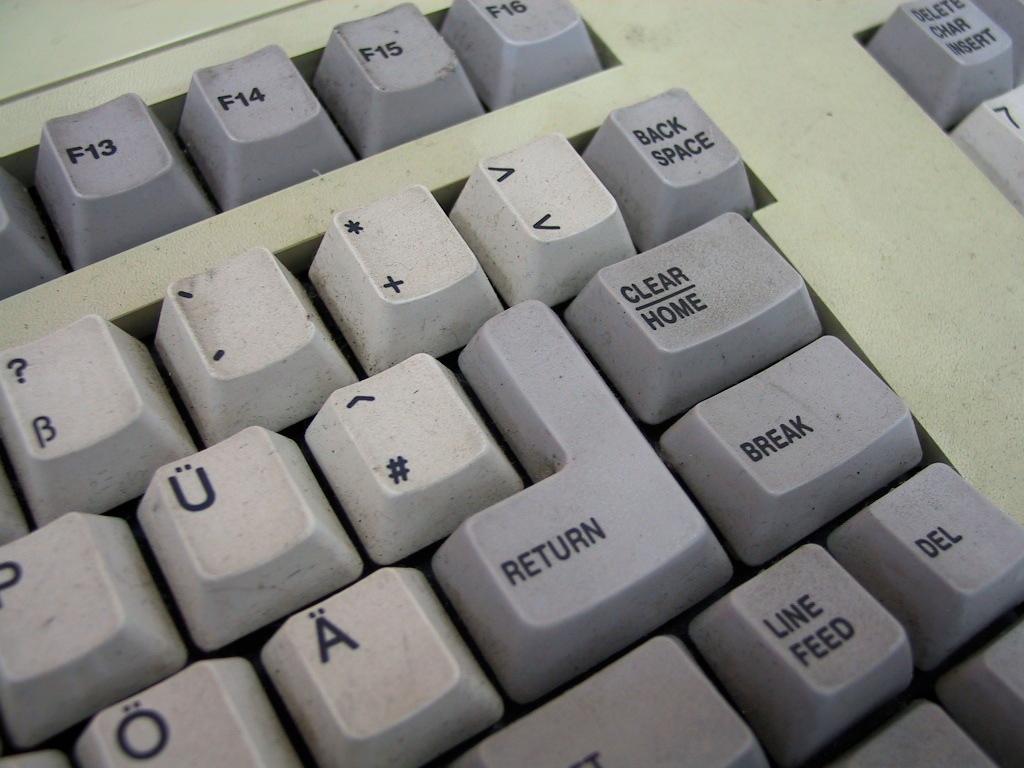What is the big key that is shaped like a backwards l do?
Provide a succinct answer. Return. 